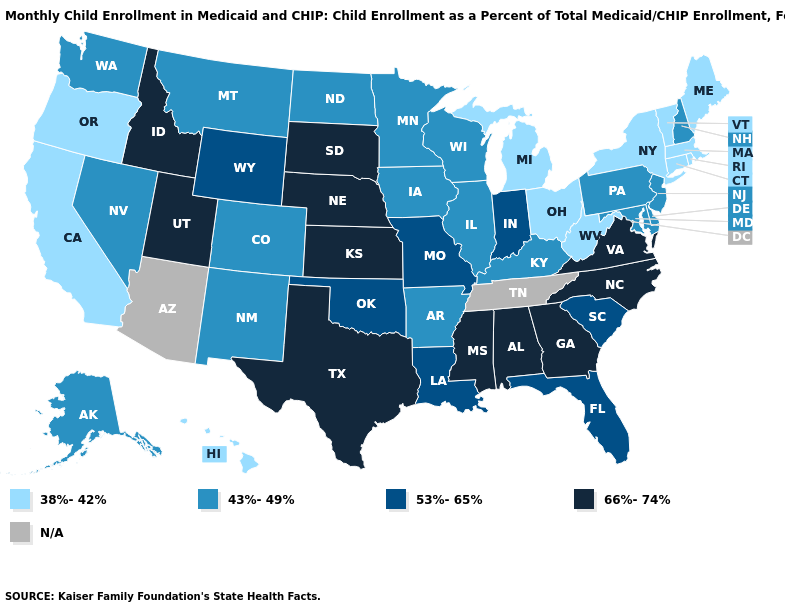Name the states that have a value in the range N/A?
Be succinct. Arizona, Tennessee. Which states have the lowest value in the USA?
Give a very brief answer. California, Connecticut, Hawaii, Maine, Massachusetts, Michigan, New York, Ohio, Oregon, Rhode Island, Vermont, West Virginia. Does West Virginia have the lowest value in the USA?
Give a very brief answer. Yes. What is the value of Michigan?
Answer briefly. 38%-42%. Name the states that have a value in the range 53%-65%?
Write a very short answer. Florida, Indiana, Louisiana, Missouri, Oklahoma, South Carolina, Wyoming. Name the states that have a value in the range N/A?
Concise answer only. Arizona, Tennessee. What is the value of Oregon?
Concise answer only. 38%-42%. What is the value of Hawaii?
Concise answer only. 38%-42%. What is the lowest value in the USA?
Short answer required. 38%-42%. Name the states that have a value in the range N/A?
Short answer required. Arizona, Tennessee. What is the highest value in states that border Oklahoma?
Be succinct. 66%-74%. 